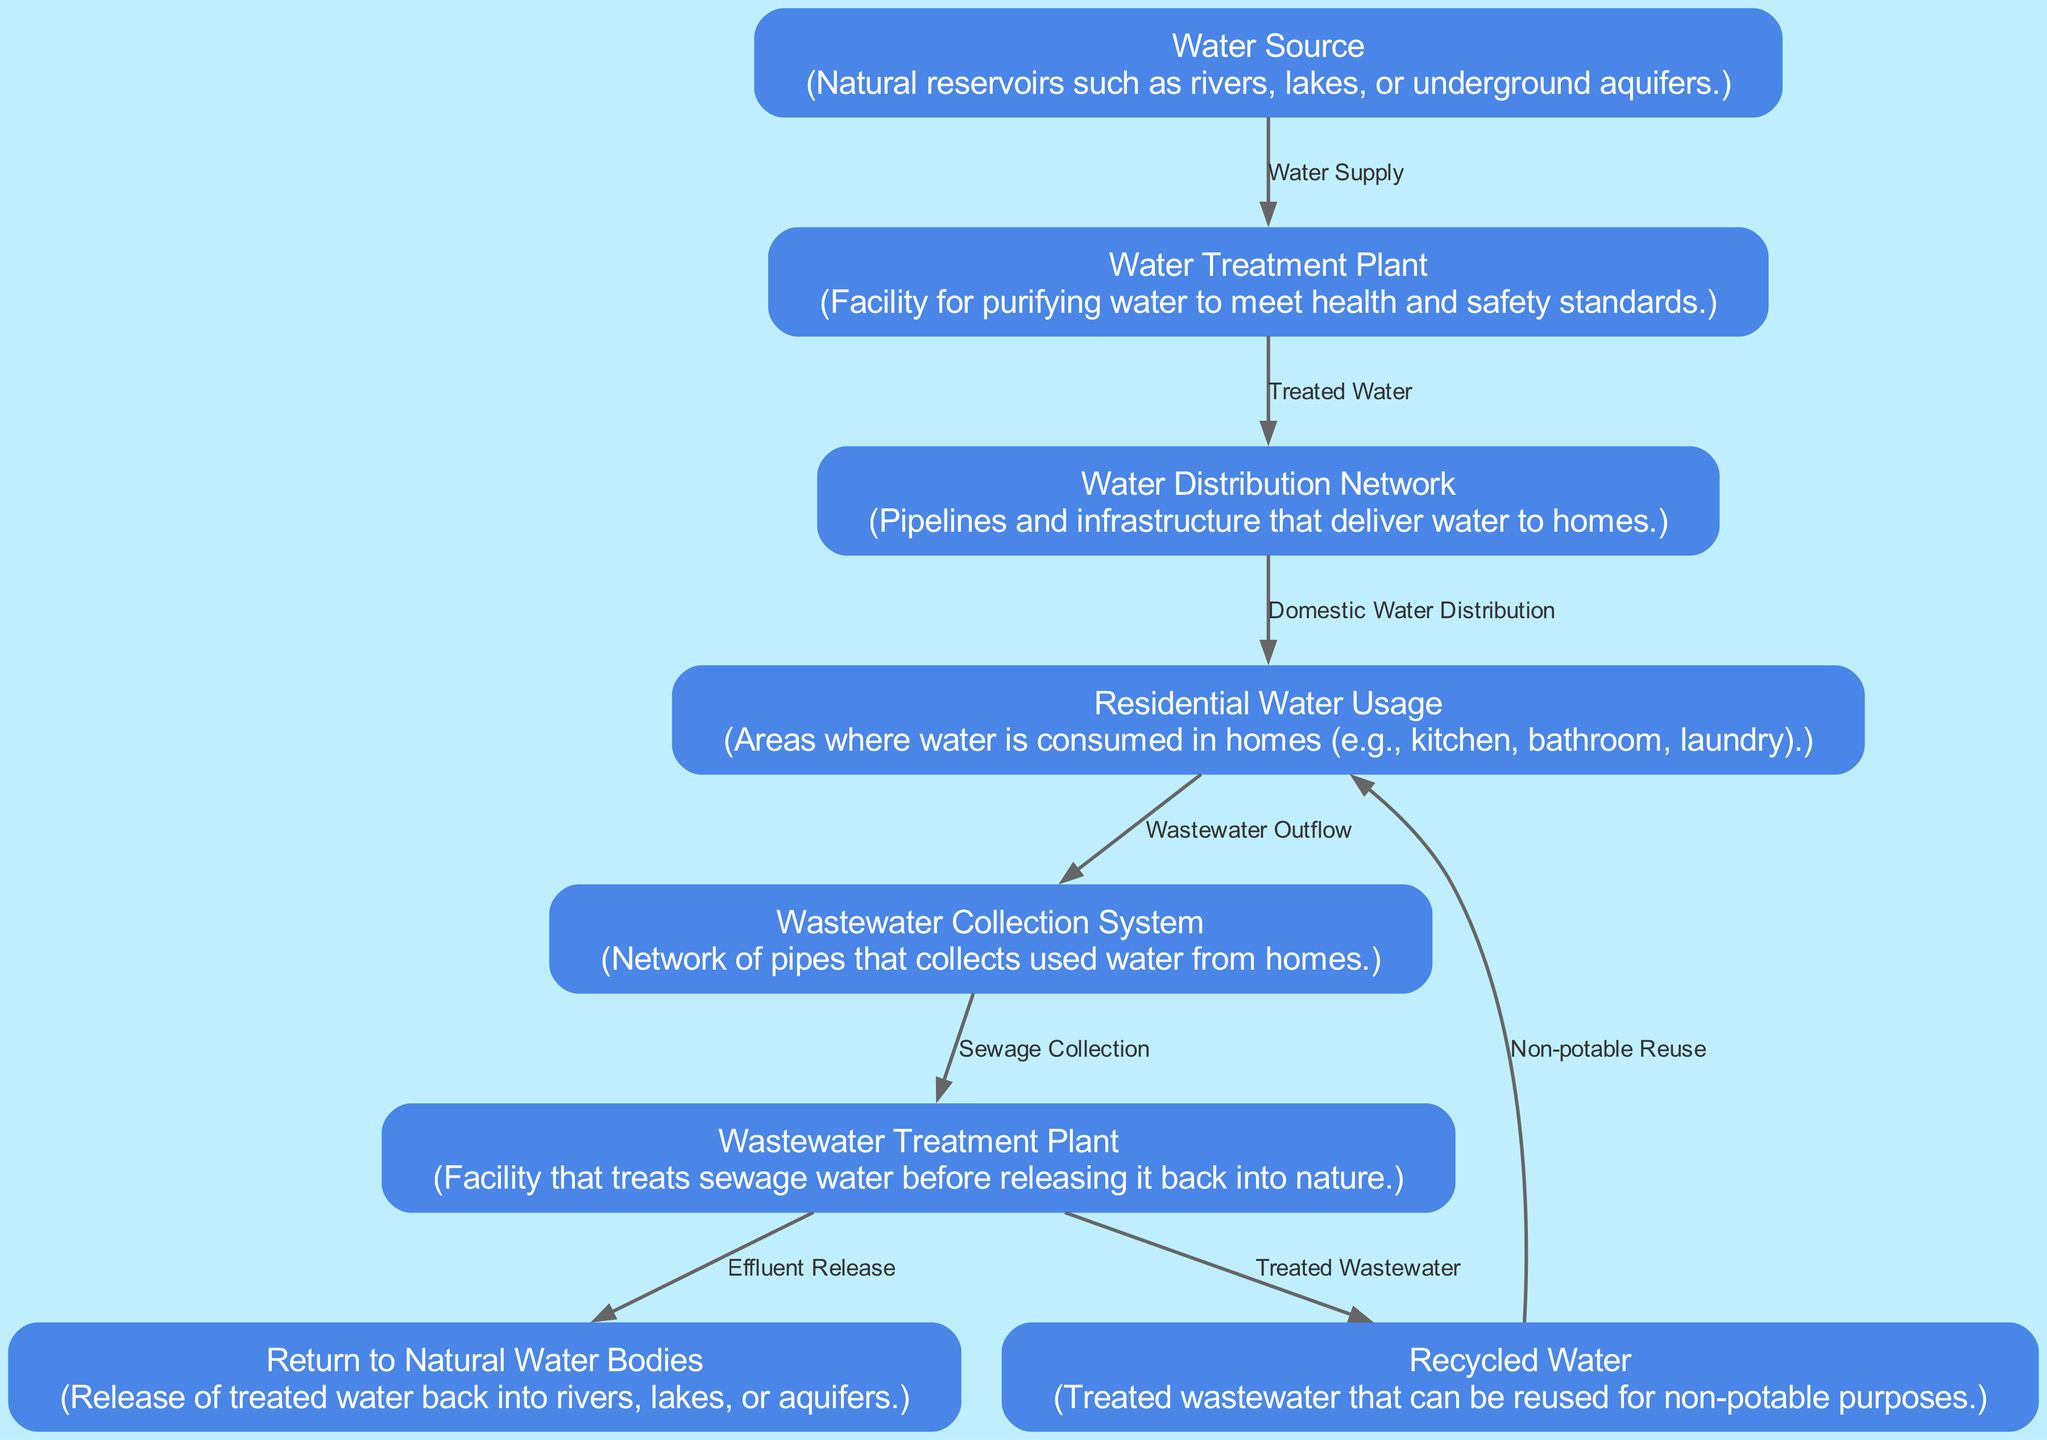What is the starting point in the water usage lifecycle? The diagram shows that the lifecycle begins at the "Water Source," which refers to natural reservoirs like rivers, lakes, or underground aquifers.
Answer: Water Source How many nodes are present in the diagram? By counting the unique nodes listed, there are eight nodes in total describing different stages of water usage.
Answer: 8 What is the final destination for treated wastewater? The diagram indicates that treated wastewater can be released back into natural water bodies, such as rivers or lakes, which is represented by the "Return to Natural Water Bodies" node.
Answer: Return to Natural Water Bodies Which node follows the "Residential Water Usage" node? According to the flow in the diagram, the next node that follows "Residential Water Usage" is the "Wastewater Collection System." This shows the movement from where water is used to where it is collected as wastewater.
Answer: Wastewater Collection System What type of water does the "Wastewater Treatment Plant" handle? The "Wastewater Treatment Plant" processes sewage water, specifically treating it to remove contaminants before it can be purified and possibly reused.
Answer: Sewage water What is the relationship between "Wastewater Treatment Plant" and "Recycled Water"? The diagram indicates that the treated output from the "Wastewater Treatment Plant" can become "Recycled Water," which is reused for non-potable purposes. This shows a direct process where treated wastewater gets repurposed.
Answer: Treated Wastewater What is the primary function of the "Water Treatment Plant"? The "Water Treatment Plant" is primarily responsible for purifying water to ensure it meets health and safety standards before being distributed for residential use.
Answer: Purifying water How does water flow from the "Water Source" to the "Residential Water Usage"? The flow starts from the "Water Source," which supplies water to the "Water Treatment Plant," where it is treated. Next, water moves to the "Water Distribution Network," which delivers it to homes, culminating in "Residential Water Usage." This progression shows the complete pathway from sourcing to usage.
Answer: Water Supply, Treated Water, Domestic Water Distribution What happens to wastewater after collection from homes? After wastewater is collected from residential areas via the "Wastewater Collection System," it is sent to the "Wastewater Treatment Plant" for treatment before being released or recycled. This sequence details what occurs after the water is used in homes.
Answer: Sent to treatment What enables the non-potable reuse of treated wastewater? The "Recycled Water" node represents treated wastewater that has been processed and is now ready for reuse in non-potable applications, indicating that treatment makes it safe for such purposes.
Answer: Treated Wastewater 